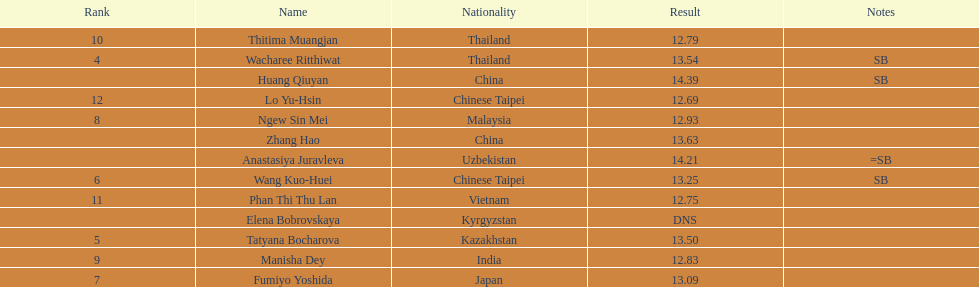Which country had the most competitors ranked in the top three in the event? China. 